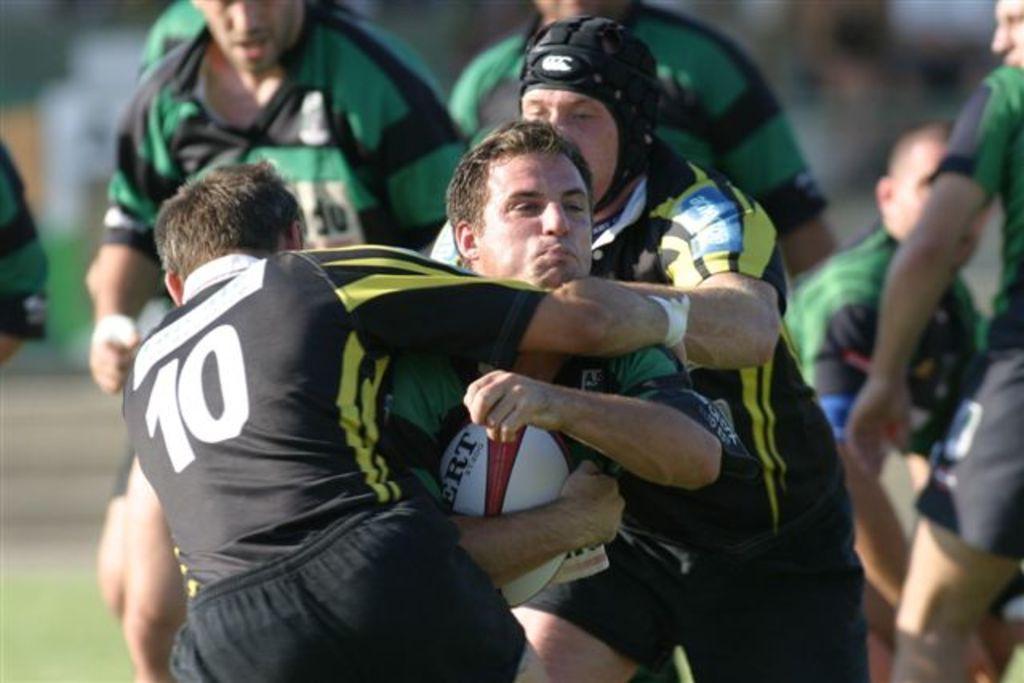Could you give a brief overview of what you see in this image? In this picture there are group of persons in the ground. In the middle, there is a man, he is wearing a green t shirt and holding a ball. In front of him there is another man, he is wearing black t shirt and black short is stopping him, there is another person behind him wearing a black t shirt and black helmet is also stopping him. In the background there are group of people. 